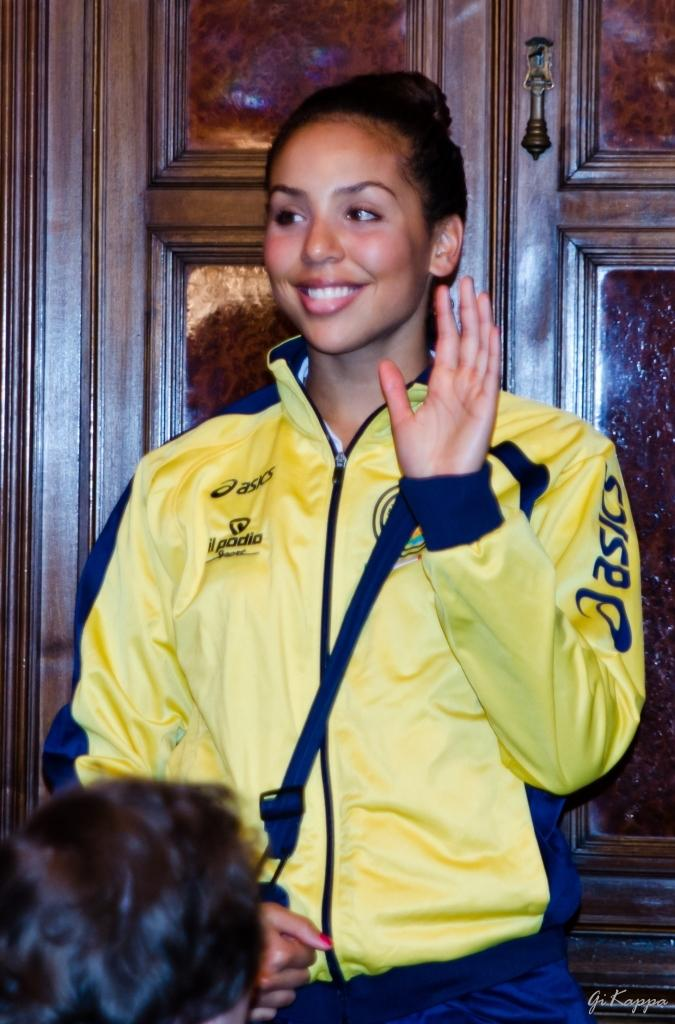<image>
Give a short and clear explanation of the subsequent image. a girl waving with a yellow jacket from asics 